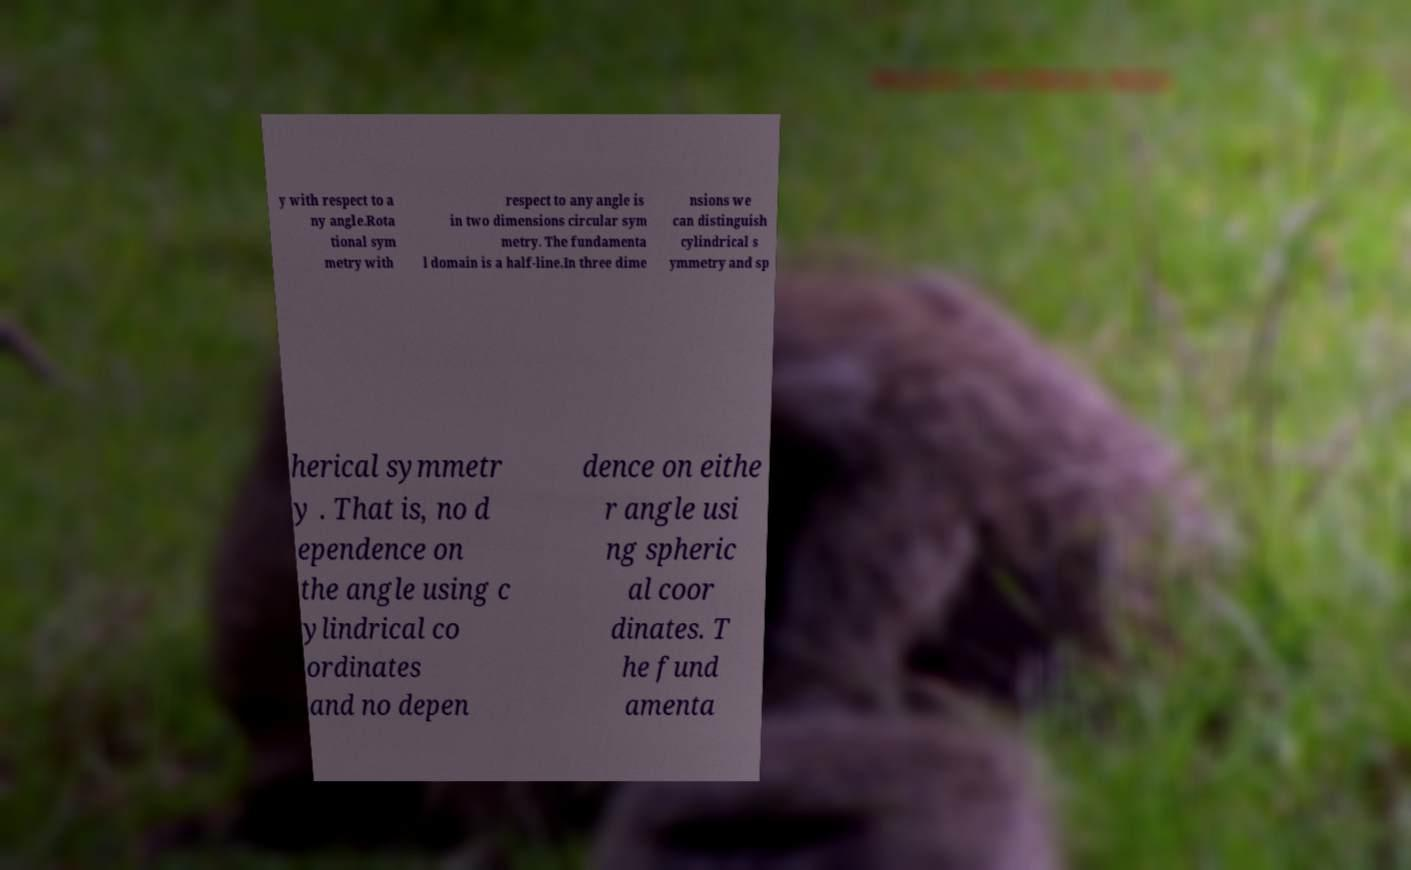There's text embedded in this image that I need extracted. Can you transcribe it verbatim? y with respect to a ny angle.Rota tional sym metry with respect to any angle is in two dimensions circular sym metry. The fundamenta l domain is a half-line.In three dime nsions we can distinguish cylindrical s ymmetry and sp herical symmetr y . That is, no d ependence on the angle using c ylindrical co ordinates and no depen dence on eithe r angle usi ng spheric al coor dinates. T he fund amenta 